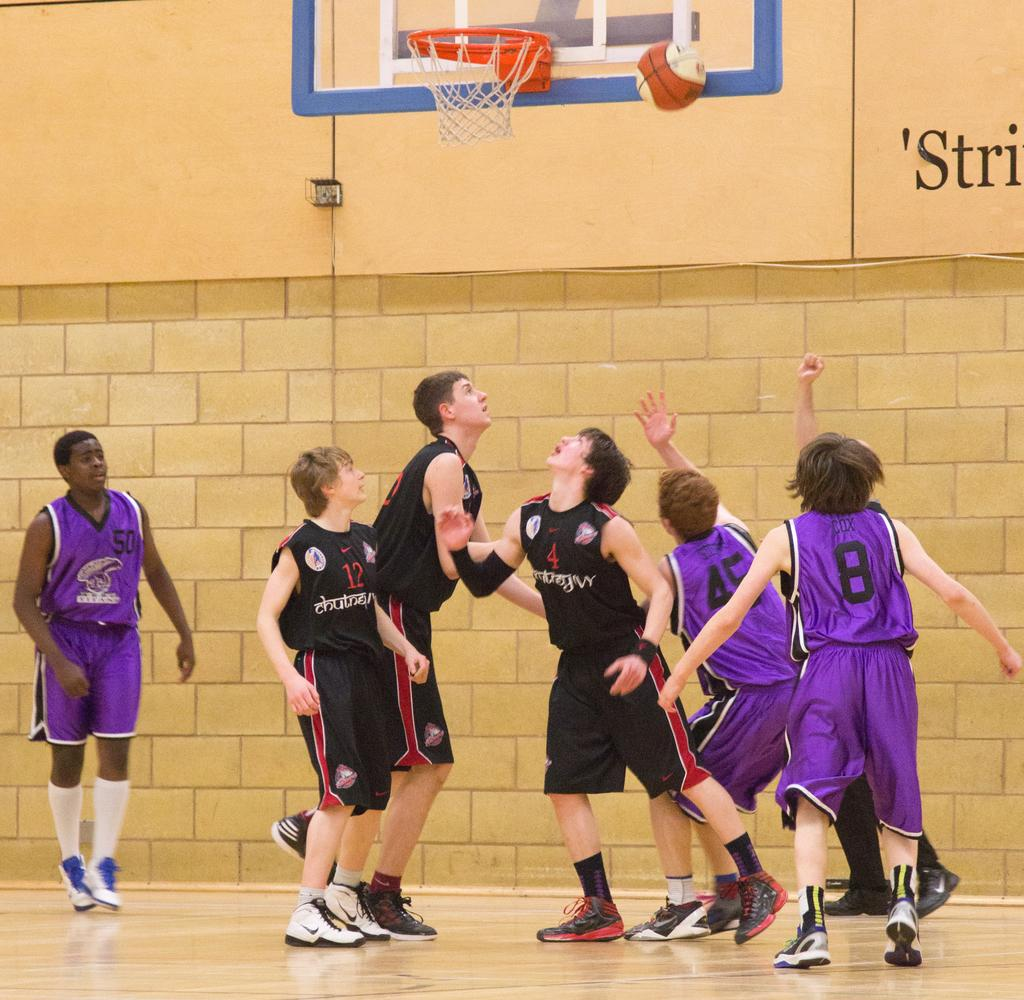What are the people in the image doing? The players in the image are on the floor, which suggests they might be playing a game. What can be seen in the background of the image? There is a wall, text, a ball, and a basketball net visible in the background of the image. What type of game might be being played in the image? The presence of a basketball net suggests that the game being played is basketball. What type of fear is the farmer experiencing while flying the plane in the image? There is no farmer or plane present in the image; it features players on the floor and a basketball net in the background. 